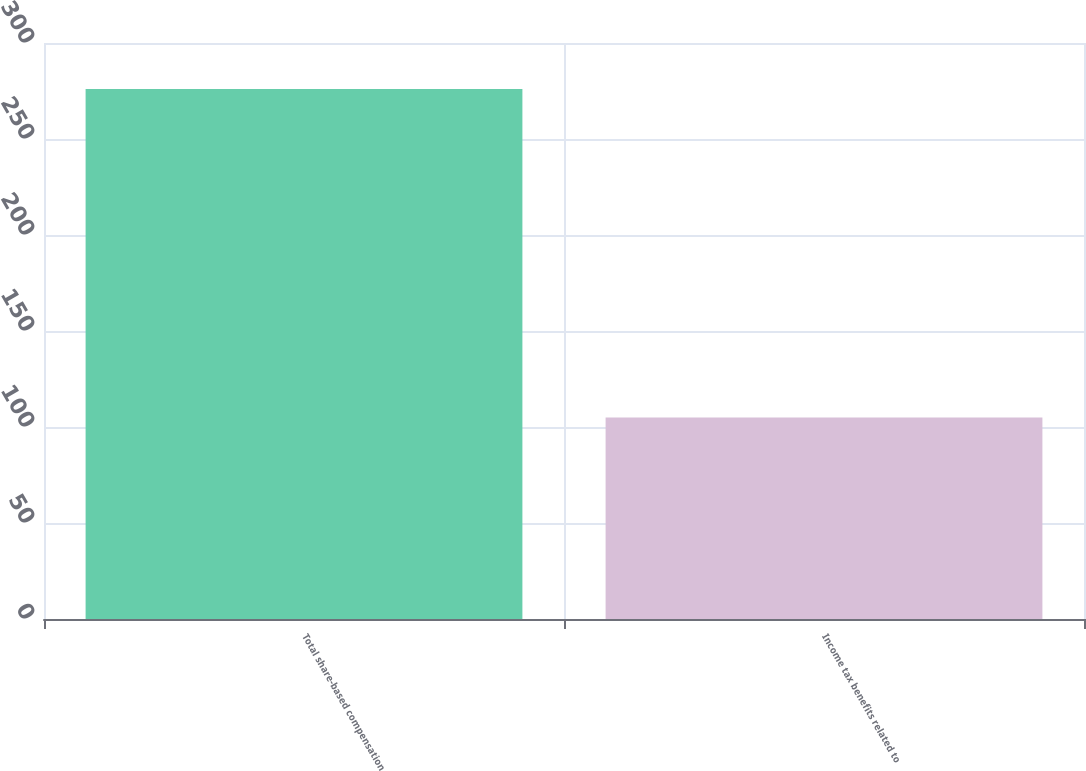Convert chart to OTSL. <chart><loc_0><loc_0><loc_500><loc_500><bar_chart><fcel>Total share-based compensation<fcel>Income tax benefits related to<nl><fcel>276<fcel>105<nl></chart> 